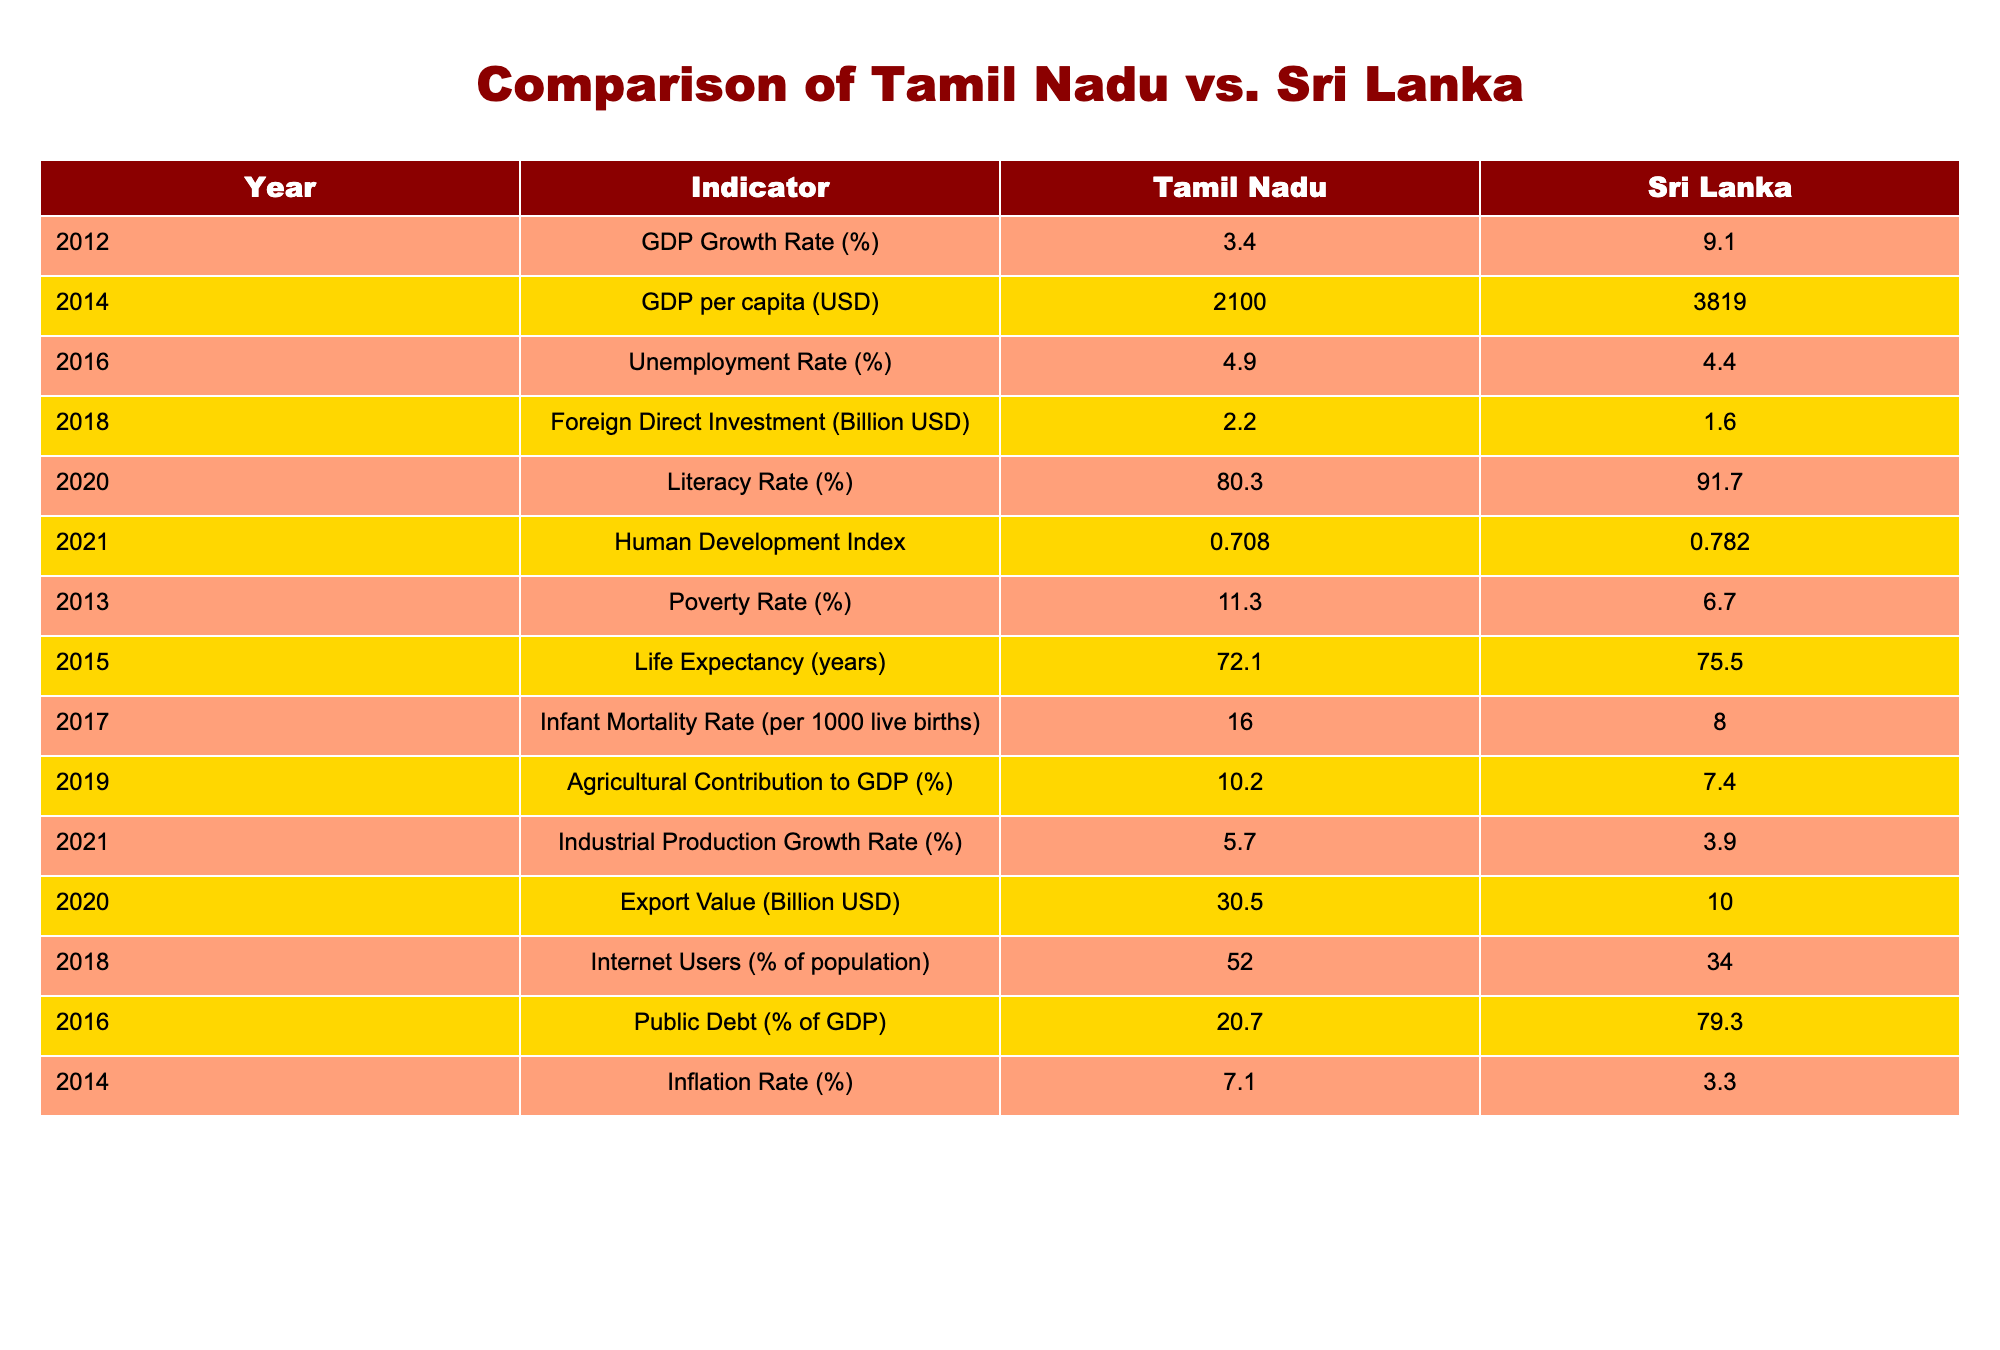What was the GDP growth rate for Sri Lanka in 2012? The table shows a specific value for the GDP growth rate of Sri Lanka in 2012, which is mentioned directly.
Answer: 9.1% What is the GDP per capita of Tamil Nadu in 2014? The table lists the GDP per capita for Tamil Nadu in 2014, which can be directly found in the specific row for that year.
Answer: 2100 USD Which region had a higher literacy rate in 2020? The table provides the literacy rates for both Tamil Nadu and Sri Lanka in 2020, allowing us to compare the two values directly. Sri Lanka has a literacy rate of 91.7%, while Tamil Nadu has 80.3%.
Answer: Sri Lanka What is the difference in life expectancy between Tamil Nadu and Sri Lanka in 2015? To find the difference, we need to subtract the life expectancy of Tamil Nadu (72.1 years) from that of Sri Lanka (75.5 years). The calculation yields 75.5 - 72.1 = 3.4 years.
Answer: 3.4 years Did Tamil Nadu have a lower unemployment rate than Sri Lanka in 2016? We can directly compare the unemployment rates from the table for 2016. Tamil Nadu's rate is 4.9%, while Sri Lanka's is 4.4%. Since 4.9% is higher than 4.4%, the statement is false.
Answer: No What is the average inflation rate of Sri Lanka from 2014 to 2016? First, we find the inflation rates for Sri Lanka in 2014 (3.3%) and 2016 (not provided), so we focus only on the provided data point for 2014. However, if considering average based only on one value, it would be 3.3%. In general terms, to calculate an average, we need to sum up values and divide by the number of values. Since we don't have all years, we can't compute a true average. Nevertheless, since we only have one data point:
Answer: 3.3% What was the percentage of Internet users in Tamil Nadu in 2018? The table provides the percentage of Internet users for Tamil Nadu directly for the year 2018, allowing for an easy retrieval of this information.
Answer: 52% Which region had a higher foreign direct investment in 2018? In the table, we can find the foreign direct investment values for both Tamil Nadu (2.2 billion USD) and Sri Lanka (1.6 billion USD) for 2018. Comparing these two, Tamil Nadu had a higher amount.
Answer: Tamil Nadu What is the sum of the agricultural contribution to GDP for both regions in 2019? The table lists the agricultural contribution to GDP for Tamil Nadu (10.2%) and Sri Lanka (7.4%) in 2019. We will add these two percentages together: 10.2 + 7.4 = 17.6%.
Answer: 17.6% 